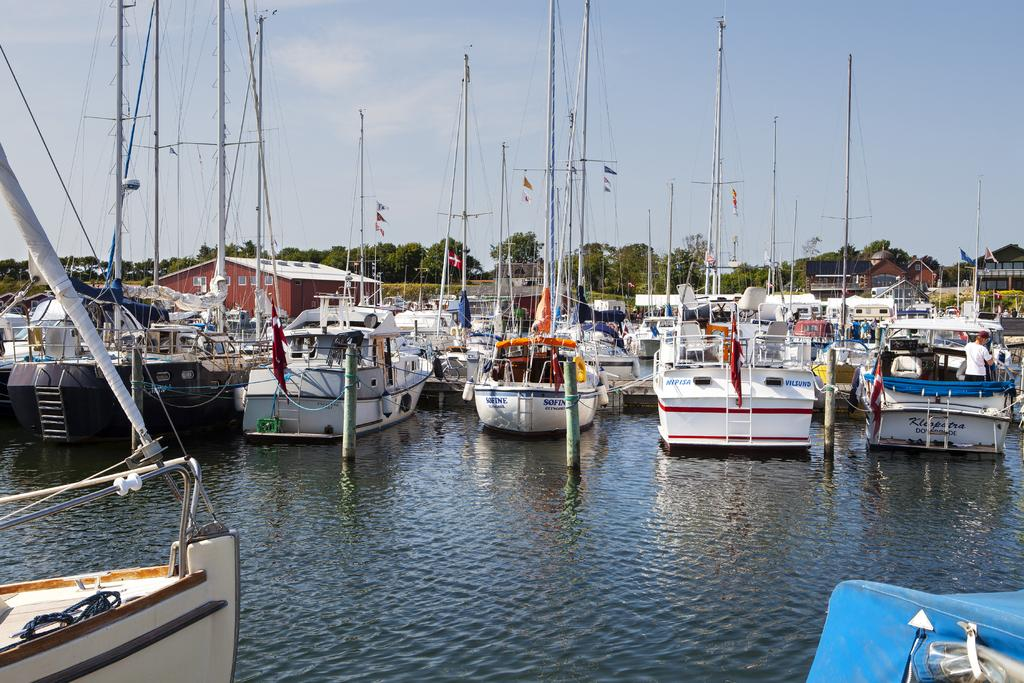What is floating on the water in the image? There are boats floating on the water in the image. What can be seen in the middle of the image? There are trees in the middle of the image. What is visible at the top of the image? The sky is visible at the top of the image. Can you see a face in the trees in the image? There is no face visible in the trees in the image. Is the area around the boats quiet in the image? The provided facts do not give information about the noise level in the image, so we cannot determine if the area around the boats is quiet or not. 